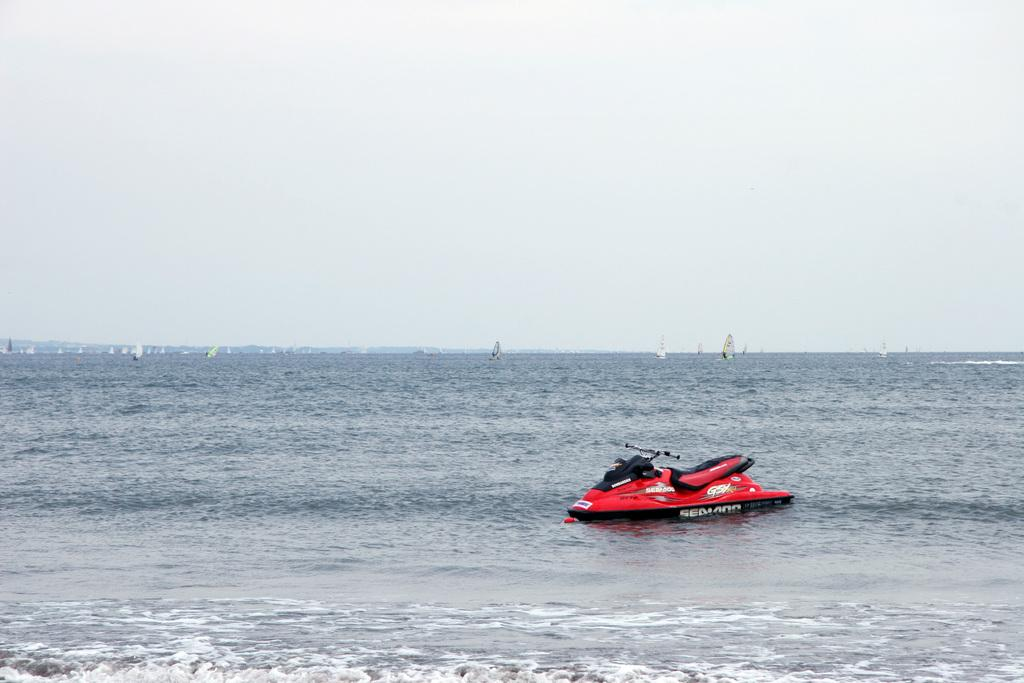What color is the boat in the image? The boat is red in the image. Where is the boat located? The boat is on the ocean in the image. What is a characteristic of the ocean? The ocean has tides. Can you describe the background of the image? There are boats in the background and clouds in the sky. What is the color of the sky? The sky is blue in the image. How many dimes are floating on the water near the boat? There are no dimes visible in the image; it features a red boat on the ocean with boats in the background and clouds in the sky. 